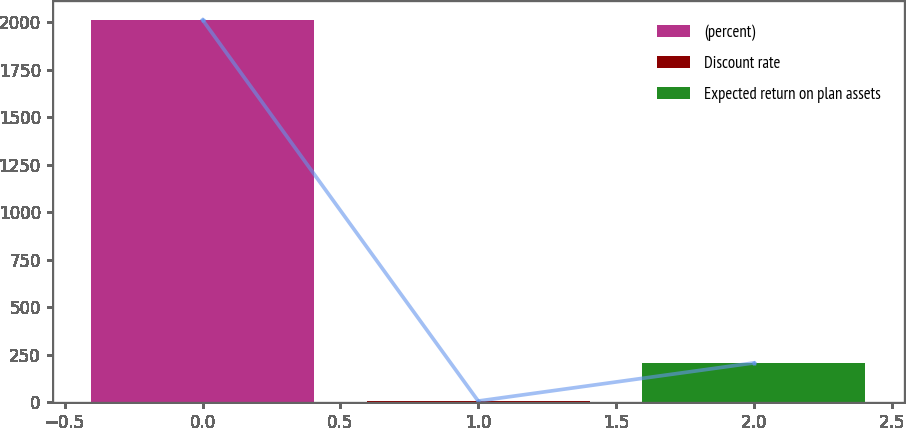Convert chart. <chart><loc_0><loc_0><loc_500><loc_500><bar_chart><fcel>(percent)<fcel>Discount rate<fcel>Expected return on plan assets<nl><fcel>2013<fcel>4.92<fcel>205.73<nl></chart> 